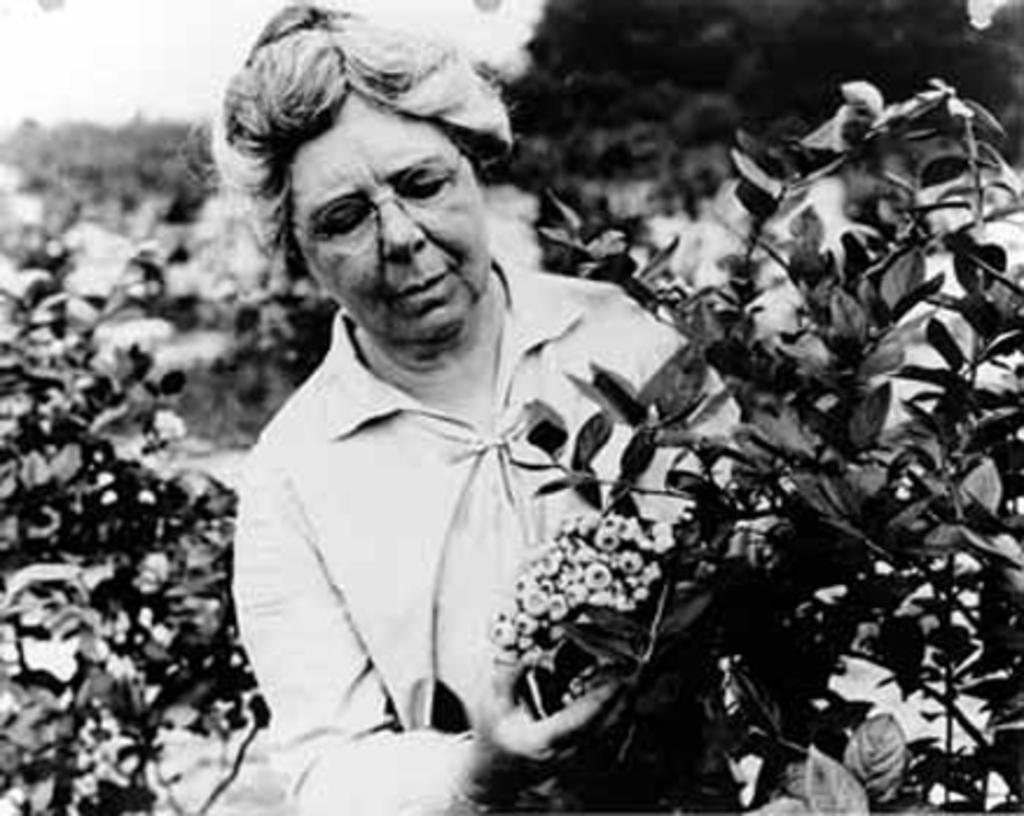Who is the main subject in the image? There is a woman in the center of the image. What is the woman doing in the image? The woman is standing in the image. What is the woman holding in the image? The woman is holding flowers in the image. What can be seen in the background of the image? There are plants in the background of the image. How many children are present in the image? There are no children present in the image; it features a woman holding flowers. What type of secretary is visible in the image? There is no secretary present in the image. 